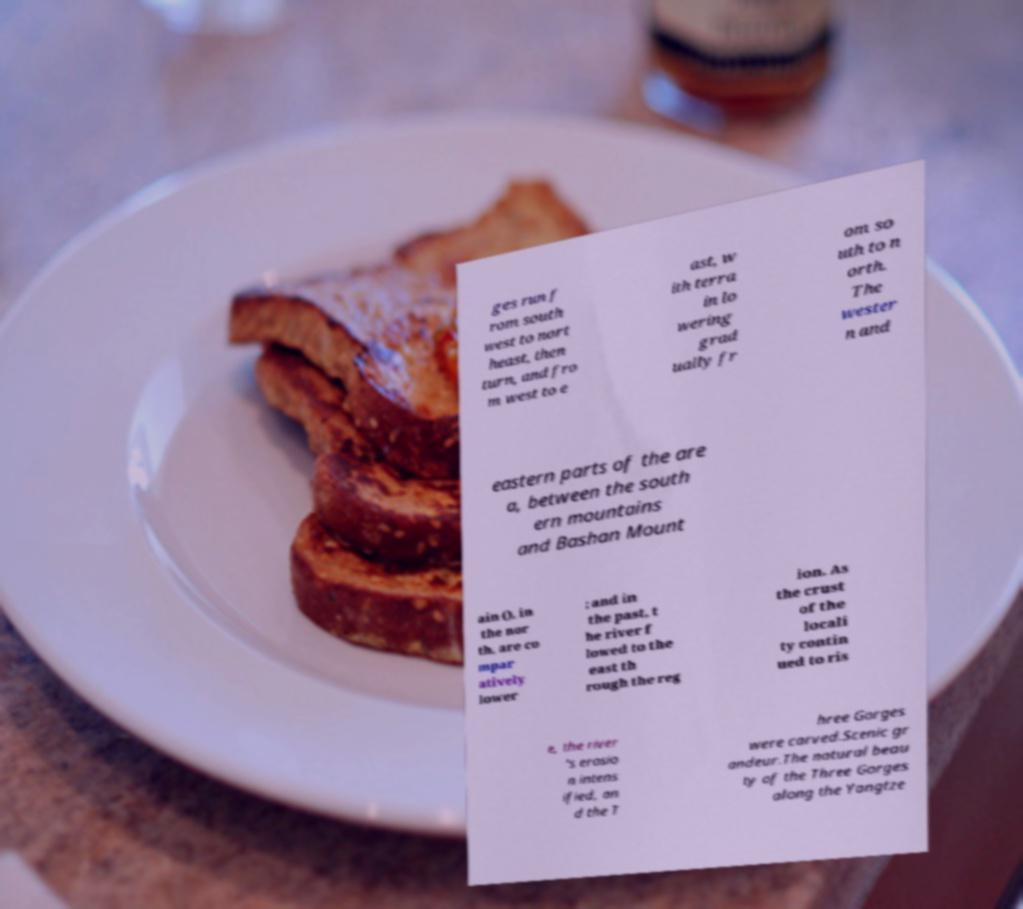Could you extract and type out the text from this image? ges run f rom south west to nort heast, then turn, and fro m west to e ast, w ith terra in lo wering grad ually fr om so uth to n orth. The wester n and eastern parts of the are a, between the south ern mountains and Bashan Mount ain (), in the nor th, are co mpar atively lower ; and in the past, t he river f lowed to the east th rough the reg ion. As the crust of the locali ty contin ued to ris e, the river 's erosio n intens ified, an d the T hree Gorges were carved.Scenic gr andeur.The natural beau ty of the Three Gorges along the Yangtze 